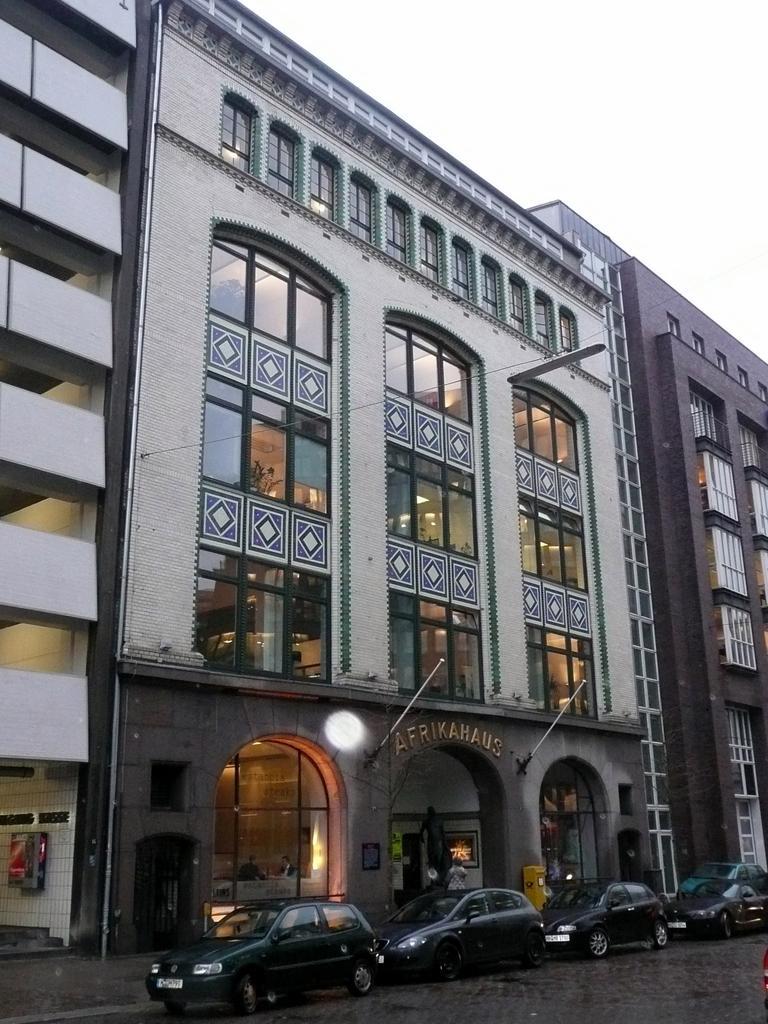How would you summarize this image in a sentence or two? There are cars on the road. Here we can see buildings. In the background there is sky. 